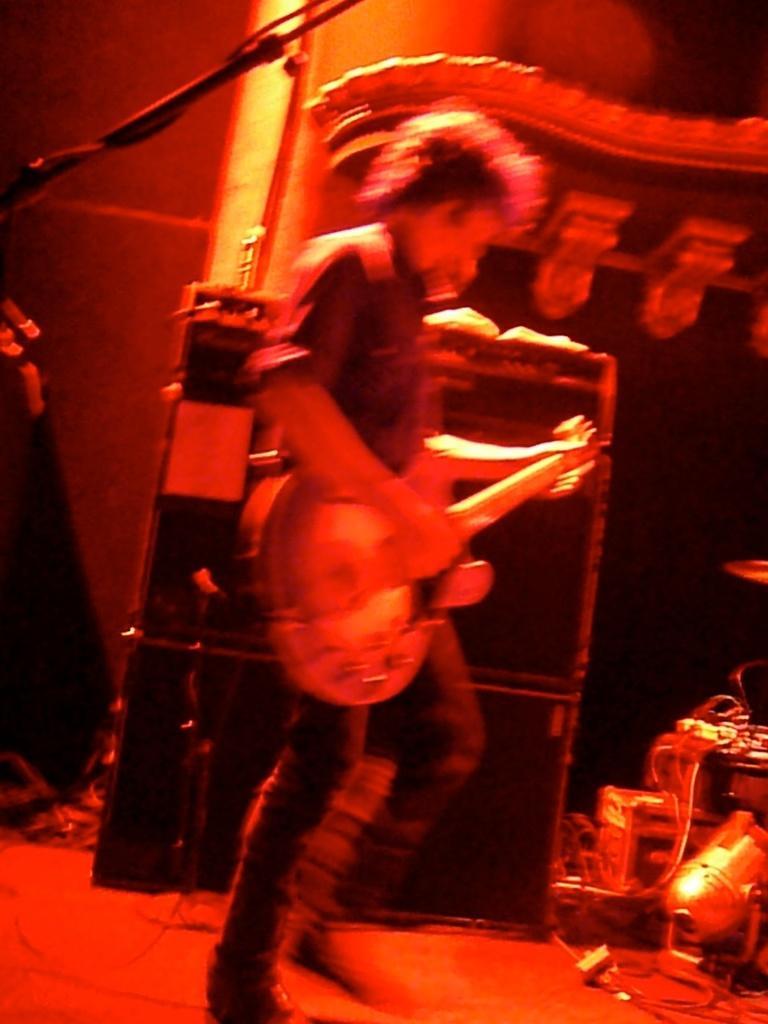Please provide a concise description of this image. In this picture we can see a man is playing guitar in front of microphone, in the background we can see some musical instruments. 